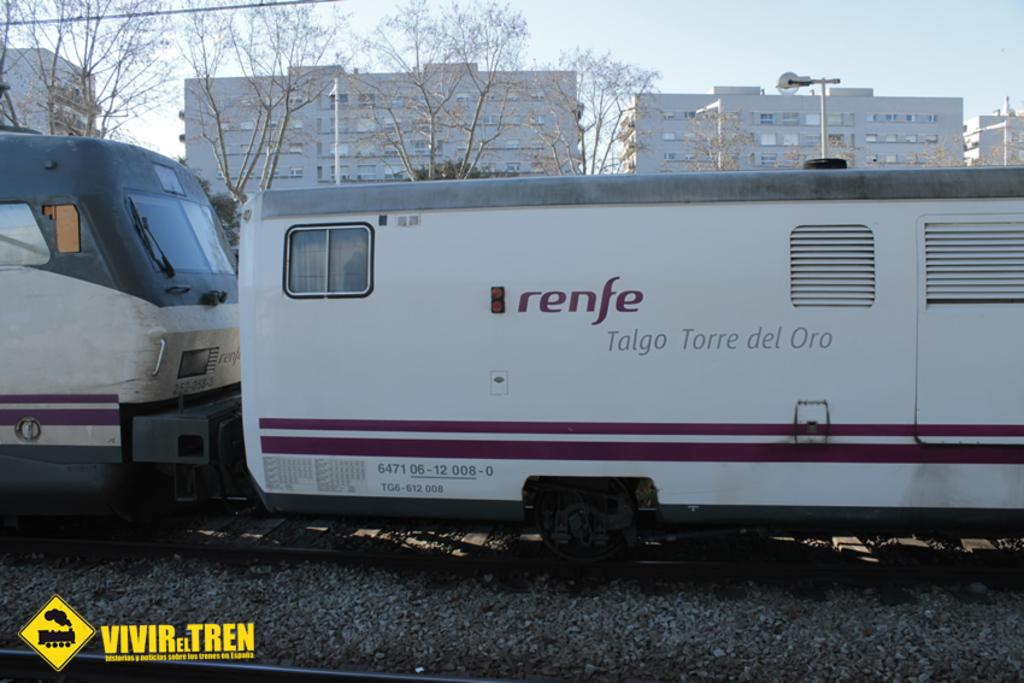What is the main subject of the image? The main subject of the image is a train. Where is the train located in the image? The train is on a railway track. What can be seen in the background of the image? There are trees, at least one building, a pole, and the sky visible in the background of the image. Who is the creator of the snake in the image? There is no snake present in the image, so it is not possible to determine who its creator might be. 